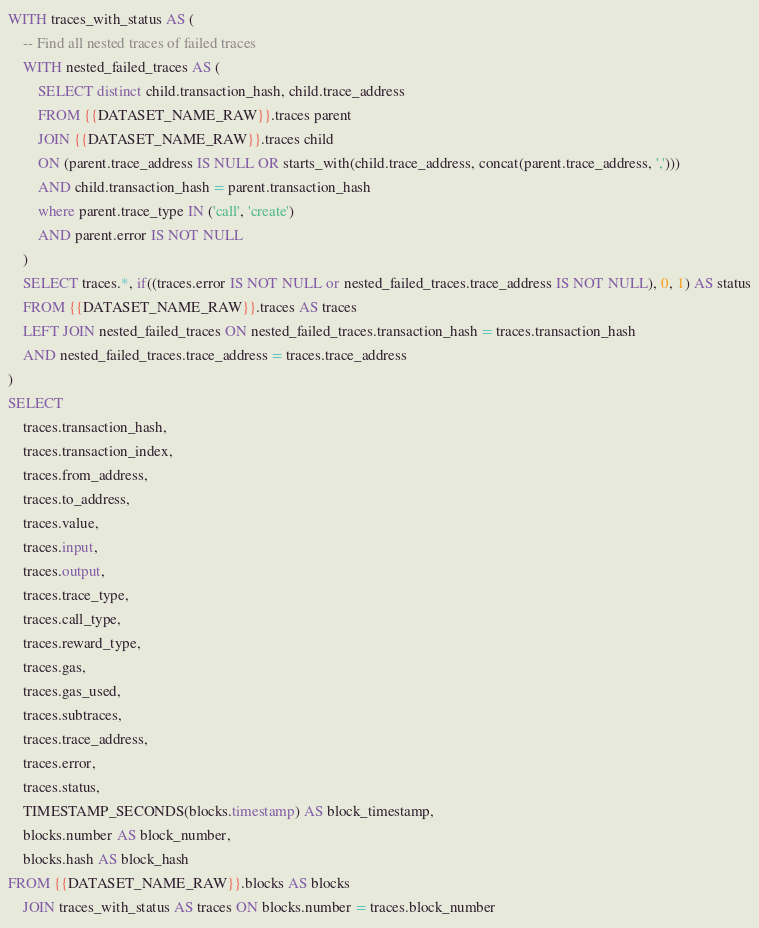<code> <loc_0><loc_0><loc_500><loc_500><_SQL_>WITH traces_with_status AS (
    -- Find all nested traces of failed traces
    WITH nested_failed_traces AS (
        SELECT distinct child.transaction_hash, child.trace_address
        FROM {{DATASET_NAME_RAW}}.traces parent
        JOIN {{DATASET_NAME_RAW}}.traces child
        ON (parent.trace_address IS NULL OR starts_with(child.trace_address, concat(parent.trace_address, ',')))
        AND child.transaction_hash = parent.transaction_hash
        where parent.trace_type IN ('call', 'create')
        AND parent.error IS NOT NULL
    )
    SELECT traces.*, if((traces.error IS NOT NULL or nested_failed_traces.trace_address IS NOT NULL), 0, 1) AS status
    FROM {{DATASET_NAME_RAW}}.traces AS traces
    LEFT JOIN nested_failed_traces ON nested_failed_traces.transaction_hash = traces.transaction_hash
    AND nested_failed_traces.trace_address = traces.trace_address
)
SELECT
    traces.transaction_hash,
    traces.transaction_index,
    traces.from_address,
    traces.to_address,
    traces.value,
    traces.input,
    traces.output,
    traces.trace_type,
    traces.call_type,
    traces.reward_type,
    traces.gas,
    traces.gas_used,
    traces.subtraces,
    traces.trace_address,
    traces.error,
    traces.status,
    TIMESTAMP_SECONDS(blocks.timestamp) AS block_timestamp,
    blocks.number AS block_number,
    blocks.hash AS block_hash
FROM {{DATASET_NAME_RAW}}.blocks AS blocks
    JOIN traces_with_status AS traces ON blocks.number = traces.block_number


</code> 